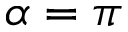Convert formula to latex. <formula><loc_0><loc_0><loc_500><loc_500>{ \alpha = \pi }</formula> 